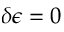<formula> <loc_0><loc_0><loc_500><loc_500>\delta \epsilon = 0</formula> 